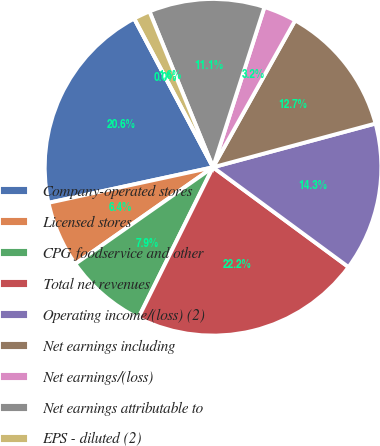<chart> <loc_0><loc_0><loc_500><loc_500><pie_chart><fcel>Company-operated stores<fcel>Licensed stores<fcel>CPG foodservice and other<fcel>Total net revenues<fcel>Operating income/(loss) (2)<fcel>Net earnings including<fcel>Net earnings/(loss)<fcel>Net earnings attributable to<fcel>EPS - diluted (2)<fcel>Cash dividends declared per<nl><fcel>20.63%<fcel>6.35%<fcel>7.94%<fcel>22.22%<fcel>14.29%<fcel>12.7%<fcel>3.17%<fcel>11.11%<fcel>1.59%<fcel>0.0%<nl></chart> 